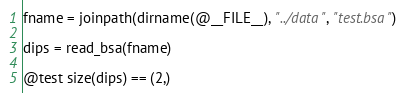<code> <loc_0><loc_0><loc_500><loc_500><_Julia_>fname = joinpath(dirname(@__FILE__), "../data", "test.bsa")

dips = read_bsa(fname)

@test size(dips) == (2,)
</code> 